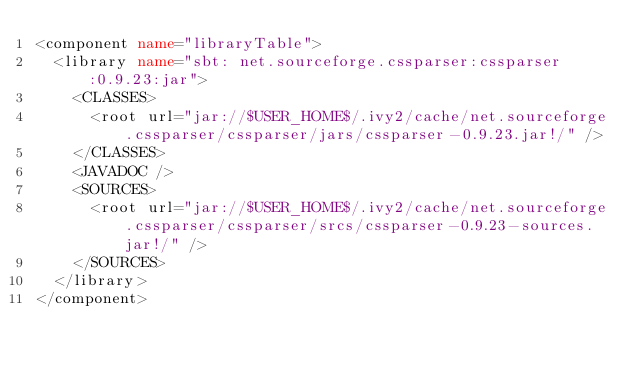<code> <loc_0><loc_0><loc_500><loc_500><_XML_><component name="libraryTable">
  <library name="sbt: net.sourceforge.cssparser:cssparser:0.9.23:jar">
    <CLASSES>
      <root url="jar://$USER_HOME$/.ivy2/cache/net.sourceforge.cssparser/cssparser/jars/cssparser-0.9.23.jar!/" />
    </CLASSES>
    <JAVADOC />
    <SOURCES>
      <root url="jar://$USER_HOME$/.ivy2/cache/net.sourceforge.cssparser/cssparser/srcs/cssparser-0.9.23-sources.jar!/" />
    </SOURCES>
  </library>
</component></code> 